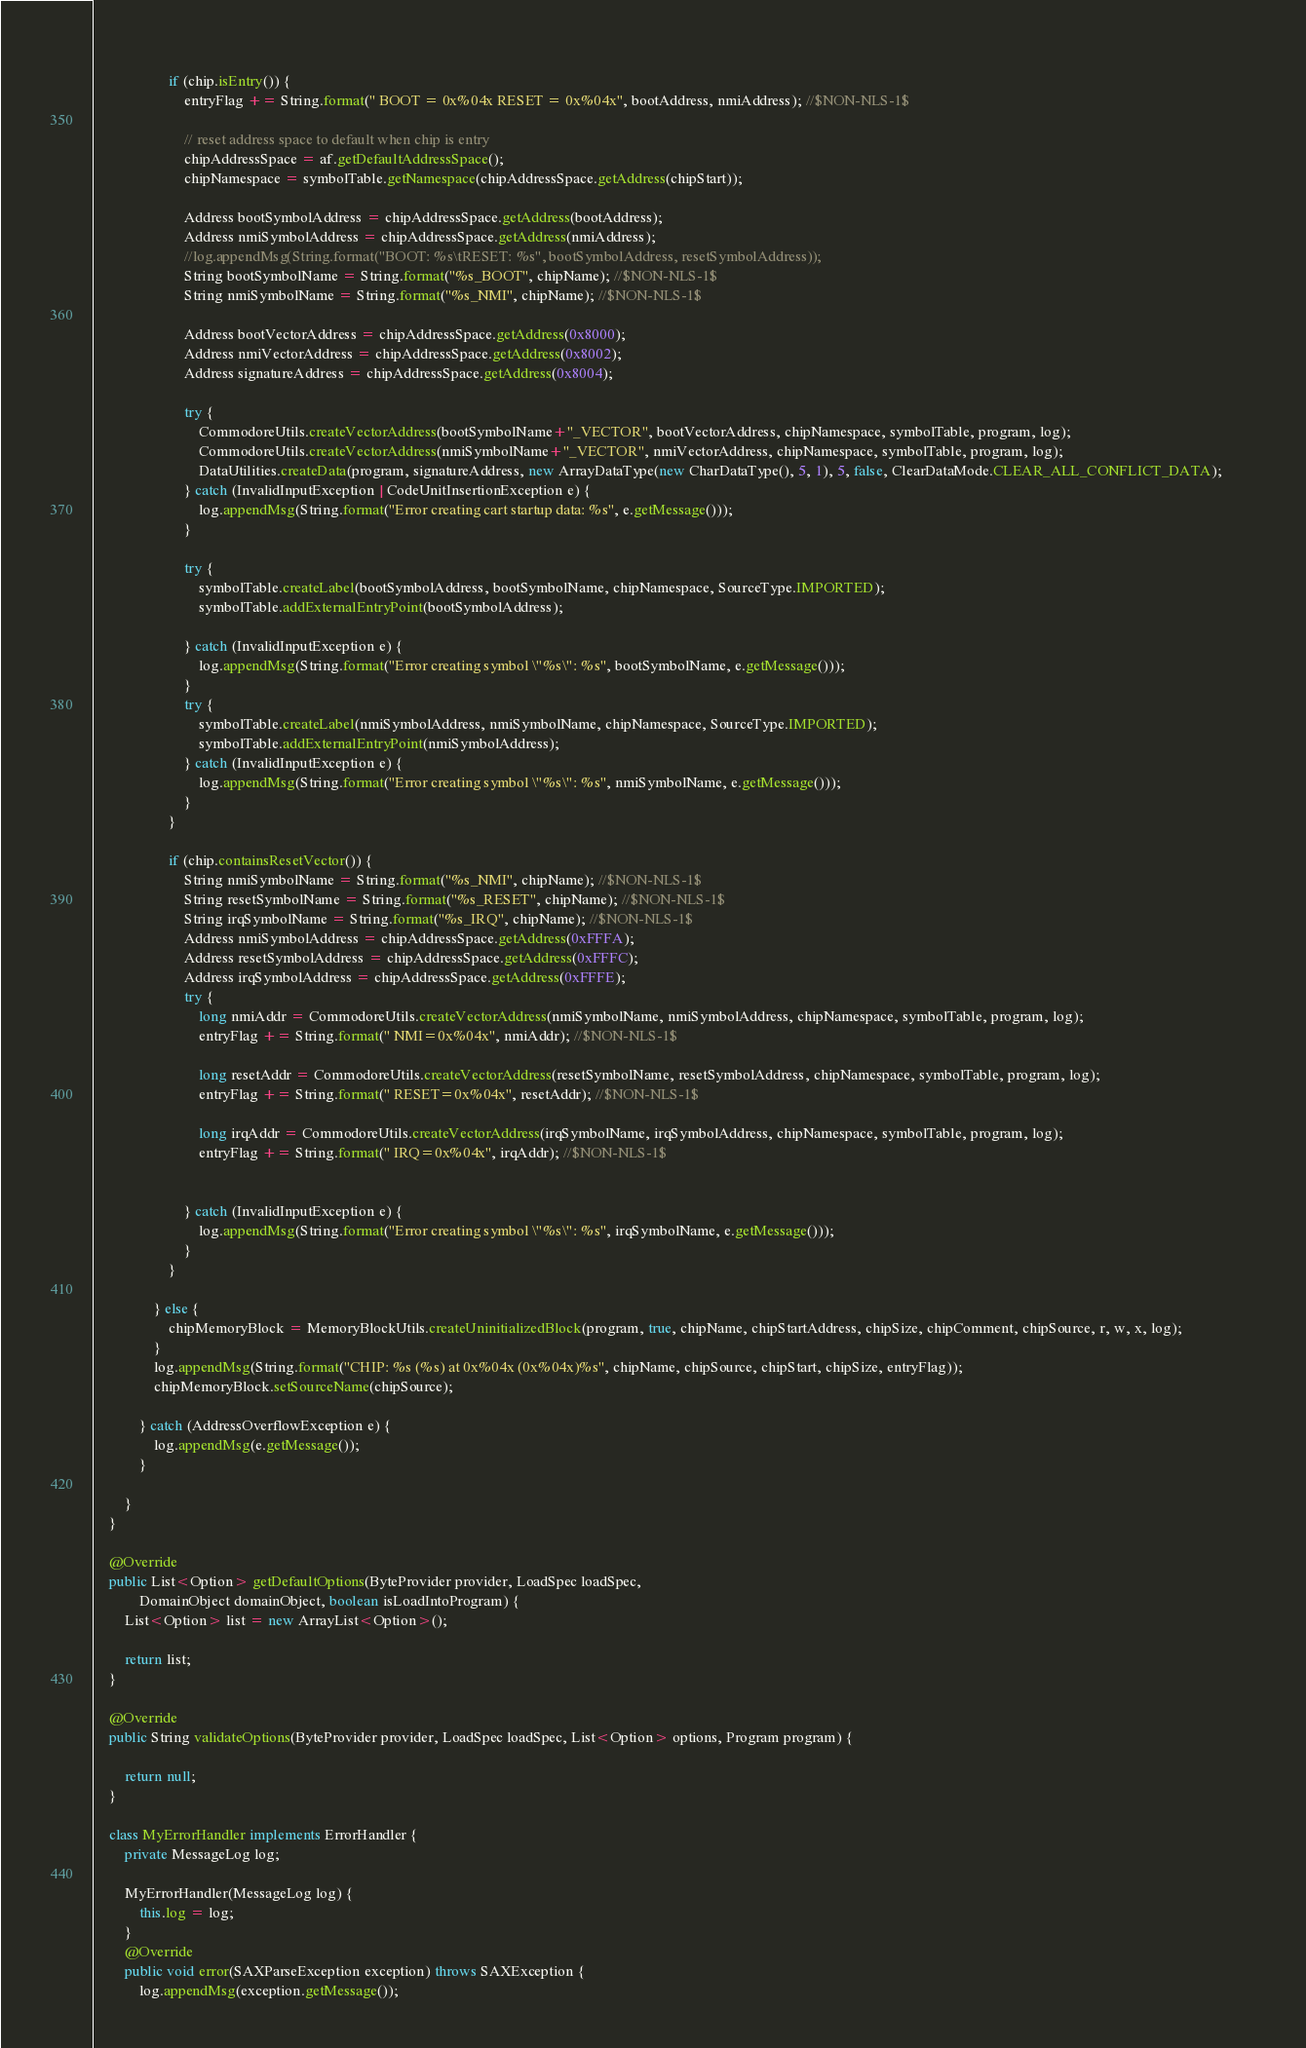<code> <loc_0><loc_0><loc_500><loc_500><_Java_>					
					if (chip.isEntry()) {
						entryFlag += String.format(" BOOT = 0x%04x RESET = 0x%04x", bootAddress, nmiAddress); //$NON-NLS-1$
						
						// reset address space to default when chip is entry
						chipAddressSpace = af.getDefaultAddressSpace();
						chipNamespace = symbolTable.getNamespace(chipAddressSpace.getAddress(chipStart));
						
						Address bootSymbolAddress = chipAddressSpace.getAddress(bootAddress);
						Address nmiSymbolAddress = chipAddressSpace.getAddress(nmiAddress);
						//log.appendMsg(String.format("BOOT: %s\tRESET: %s", bootSymbolAddress, resetSymbolAddress));
						String bootSymbolName = String.format("%s_BOOT", chipName); //$NON-NLS-1$
						String nmiSymbolName = String.format("%s_NMI", chipName); //$NON-NLS-1$
						
						Address bootVectorAddress = chipAddressSpace.getAddress(0x8000);
						Address nmiVectorAddress = chipAddressSpace.getAddress(0x8002);
						Address signatureAddress = chipAddressSpace.getAddress(0x8004);
						
						try {
							CommodoreUtils.createVectorAddress(bootSymbolName+"_VECTOR", bootVectorAddress, chipNamespace, symbolTable, program, log);
							CommodoreUtils.createVectorAddress(nmiSymbolName+"_VECTOR", nmiVectorAddress, chipNamespace, symbolTable, program, log);
							DataUtilities.createData(program, signatureAddress, new ArrayDataType(new CharDataType(), 5, 1), 5, false, ClearDataMode.CLEAR_ALL_CONFLICT_DATA);
						} catch (InvalidInputException | CodeUnitInsertionException e) {
							log.appendMsg(String.format("Error creating cart startup data: %s", e.getMessage()));
						}
						
						try {
							symbolTable.createLabel(bootSymbolAddress, bootSymbolName, chipNamespace, SourceType.IMPORTED);
							symbolTable.addExternalEntryPoint(bootSymbolAddress);
							
						} catch (InvalidInputException e) {
							log.appendMsg(String.format("Error creating symbol \"%s\": %s", bootSymbolName, e.getMessage()));
						}
						try {
							symbolTable.createLabel(nmiSymbolAddress, nmiSymbolName, chipNamespace, SourceType.IMPORTED);
							symbolTable.addExternalEntryPoint(nmiSymbolAddress);
						} catch (InvalidInputException e) {
							log.appendMsg(String.format("Error creating symbol \"%s\": %s", nmiSymbolName, e.getMessage()));
						}
					}
					
					if (chip.containsResetVector()) {
						String nmiSymbolName = String.format("%s_NMI", chipName); //$NON-NLS-1$
						String resetSymbolName = String.format("%s_RESET", chipName); //$NON-NLS-1$
						String irqSymbolName = String.format("%s_IRQ", chipName); //$NON-NLS-1$
						Address nmiSymbolAddress = chipAddressSpace.getAddress(0xFFFA);
						Address resetSymbolAddress = chipAddressSpace.getAddress(0xFFFC);
						Address irqSymbolAddress = chipAddressSpace.getAddress(0xFFFE);
						try {
							long nmiAddr = CommodoreUtils.createVectorAddress(nmiSymbolName, nmiSymbolAddress, chipNamespace, symbolTable, program, log);
							entryFlag += String.format(" NMI=0x%04x", nmiAddr); //$NON-NLS-1$
							
							long resetAddr = CommodoreUtils.createVectorAddress(resetSymbolName, resetSymbolAddress, chipNamespace, symbolTable, program, log);
							entryFlag += String.format(" RESET=0x%04x", resetAddr); //$NON-NLS-1$
							
							long irqAddr = CommodoreUtils.createVectorAddress(irqSymbolName, irqSymbolAddress, chipNamespace, symbolTable, program, log);
							entryFlag += String.format(" IRQ=0x%04x", irqAddr); //$NON-NLS-1$
							
							
						} catch (InvalidInputException e) {
							log.appendMsg(String.format("Error creating symbol \"%s\": %s", irqSymbolName, e.getMessage()));
						}
					}
										
				} else {
					chipMemoryBlock = MemoryBlockUtils.createUninitializedBlock(program, true, chipName, chipStartAddress, chipSize, chipComment, chipSource, r, w, x, log);					
				}
				log.appendMsg(String.format("CHIP: %s (%s) at 0x%04x (0x%04x)%s", chipName, chipSource, chipStart, chipSize, entryFlag));
				chipMemoryBlock.setSourceName(chipSource);
				
			} catch (AddressOverflowException e) {
				log.appendMsg(e.getMessage());				
			}
			
		}
	}
	
	@Override
	public List<Option> getDefaultOptions(ByteProvider provider, LoadSpec loadSpec,
			DomainObject domainObject, boolean isLoadIntoProgram) {
		List<Option> list = new ArrayList<Option>();

		return list;
	}

	@Override
	public String validateOptions(ByteProvider provider, LoadSpec loadSpec, List<Option> options, Program program) {

		return null;
	}
	
	class MyErrorHandler implements ErrorHandler {
		private MessageLog log;
		
		MyErrorHandler(MessageLog log) {
			this.log = log;
		}
		@Override
		public void error(SAXParseException exception) throws SAXException {
			log.appendMsg(exception.getMessage());</code> 